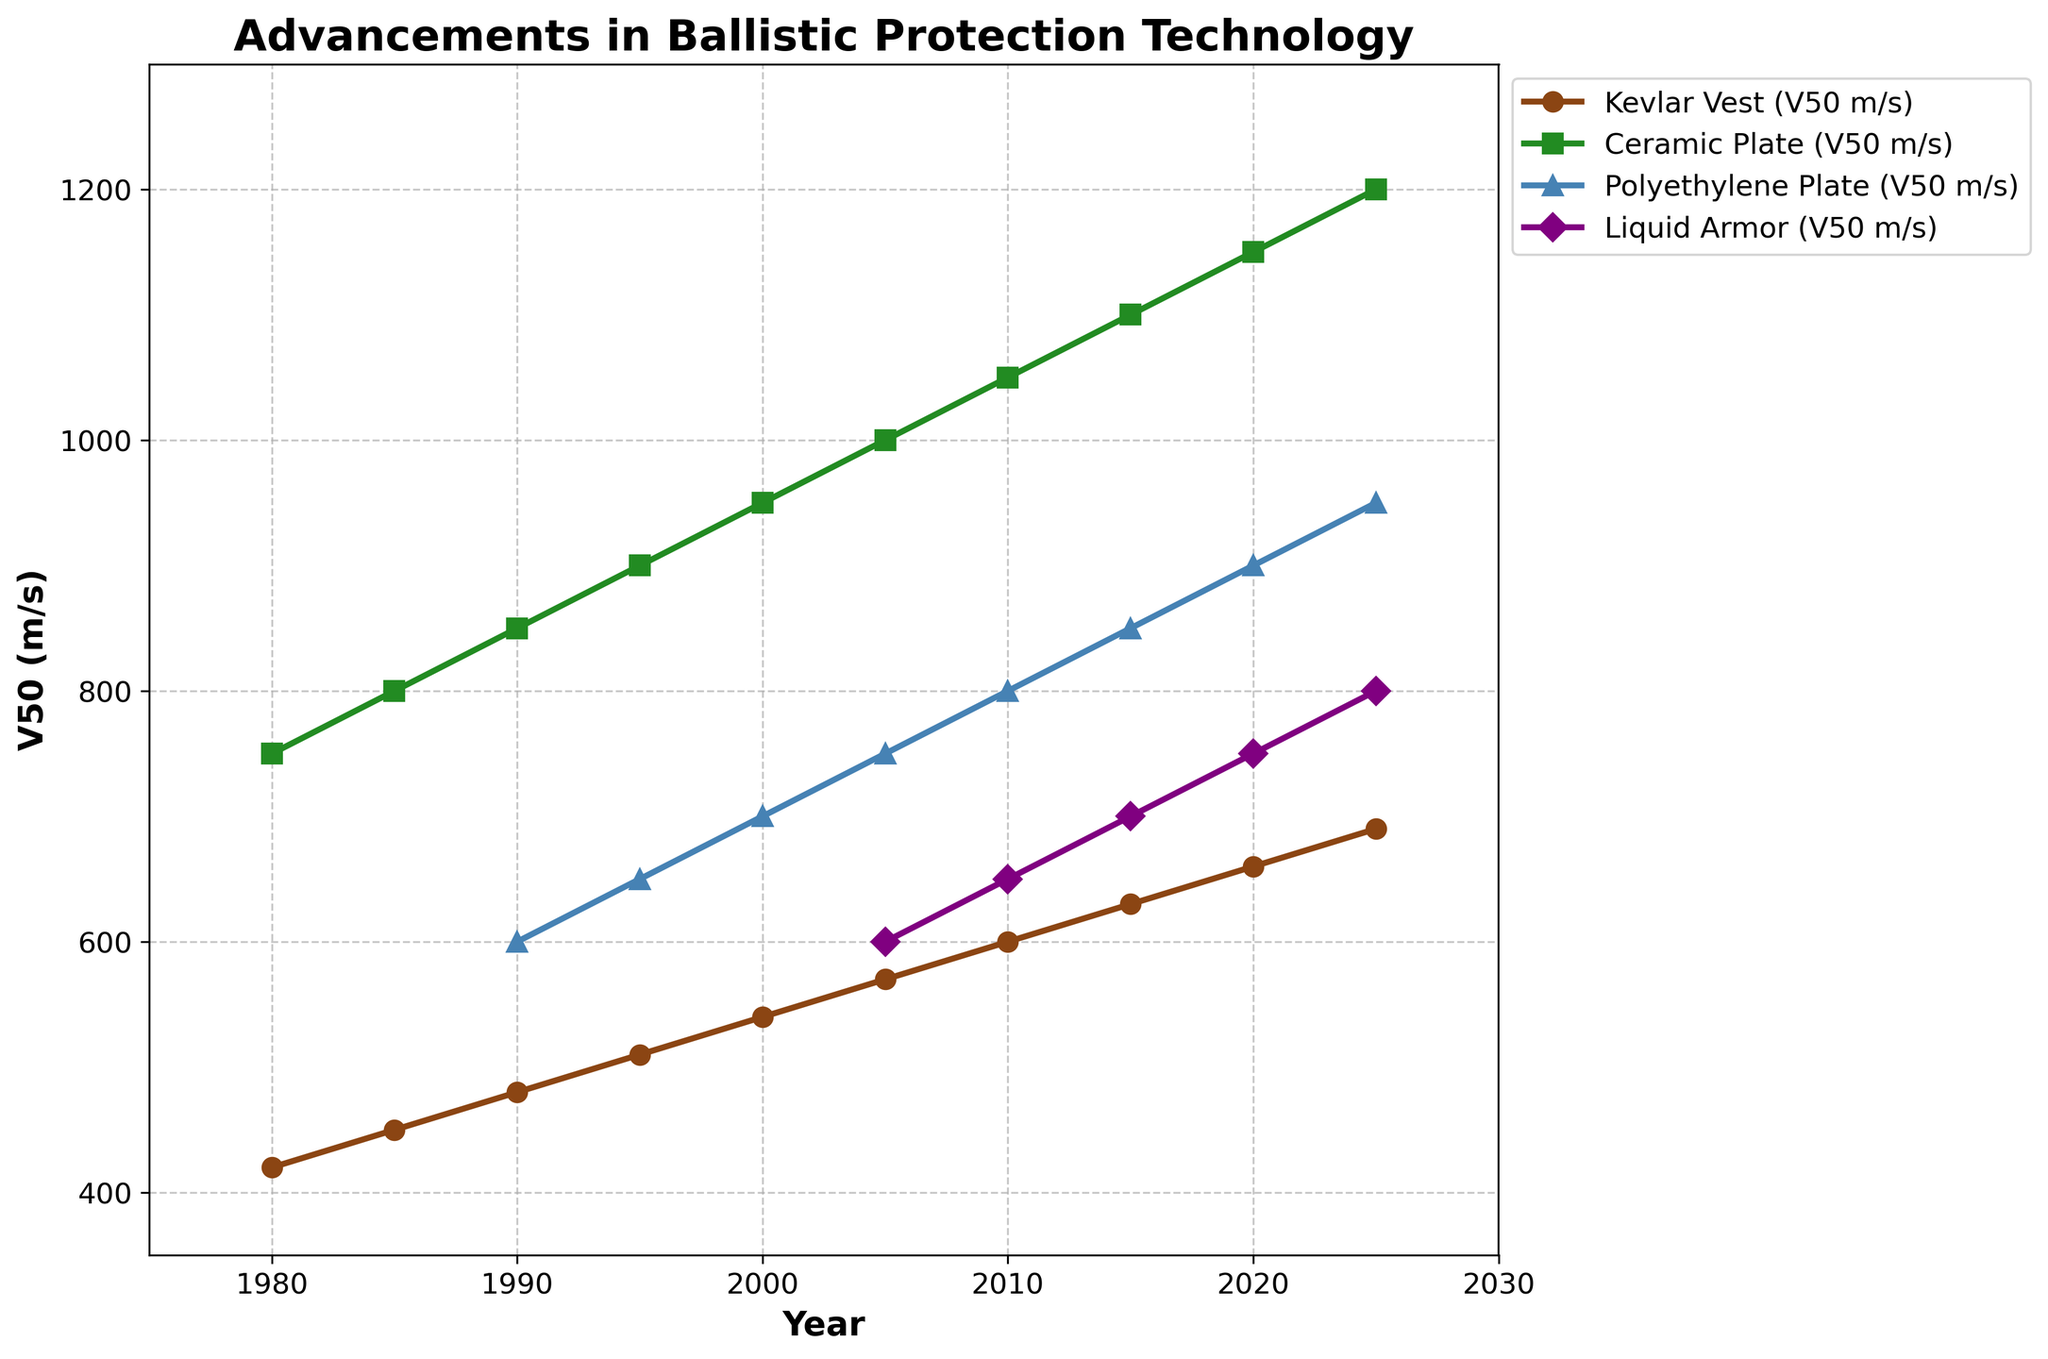Which armor type had the highest V50 value in 2025? Examine the figure and locate the 2025 data points for each armor type. The Ceramic Plate's V50 value is the highest.
Answer: Ceramic Plate What is the difference in V50 values between Polyethylene Plate and Liquid Armor in 2020? Find the V50 values for Polyethylene Plate and Liquid Armor in 2020, which are 900 m/s and 750 m/s, respectively. Calculate the difference: 900 - 750.
Answer: 150 m/s By how much did the V50 value for the Kevlar Vest increase from 1980 to 2000? Locate the V50 values for Kevlar Vest in 1980 and 2000, which are 420 m/s and 540 m/s, respectively. Calculate the increase: 540 - 420.
Answer: 120 m/s Which armor type shows the most consistent improvement in V50 values over the years? Look for the armor type with the steadiest incremental increases in V50 values. Both Kevlar Vest and Ceramic Plate show consistent improvements, but Ceramic Plate has larger and more consistent increments.
Answer: Ceramic Plate At which year did Liquid Armor first appear in the data, and what was its initial V50 value? Identify the first year Liquid Armor is shown, which is 2005, with an initial V50 value of 600 m/s.
Answer: 2005, 600 m/s What was the average V50 value of the Ceramic Plate between 1980 and 2025? Sum the V50 values for Ceramic Plate from 1980 to 2025 and divide by the number of data points (10). (750 + 800 + 850 + 900 + 950 + 1000 + 1050 + 1100 + 1150 + 1200) / 10 = 975.
Answer: 975 m/s In which year did Polyethylene Plate overtake Kevlar Vest in V50 value? Compare the V50 values of Polyethylene Plate and Kevlar Vest year by year. Polyethylene Plate exceeds Kevlar Vest in 2010: (800 vs. 600).
Answer: 2010 What is the V50 value trend for Liquid Armor from 2005 to 2025? Observe the V50 values for Liquid Armor from 2005 to 2025: 600, 650, 700, 750, 800, showing a consistent increase.
Answer: Increasing Across the observation years, which armor type had the lowest starting V50 value and in what year? Identify the lowest initial V50 value among the armor types. Kevlar Vest had the lowest starting V50 value in 1980 (420 m/s).
Answer: Kevlar Vest, 1980 